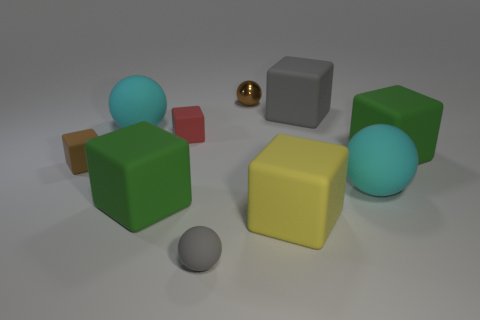Is the number of small brown rubber blocks less than the number of purple shiny cylinders?
Your answer should be compact. No. Are there more small cubes that are behind the small brown metallic ball than metal things to the right of the tiny brown block?
Make the answer very short. No. Is the material of the red block the same as the big yellow cube?
Offer a very short reply. Yes. What number of yellow rubber objects are behind the cyan matte ball left of the tiny gray object?
Make the answer very short. 0. There is a big matte sphere that is behind the tiny brown rubber thing; does it have the same color as the small rubber ball?
Your response must be concise. No. How many things are brown rubber cubes or rubber spheres that are in front of the brown rubber object?
Keep it short and to the point. 3. Does the gray rubber thing in front of the small red matte cube have the same shape as the small red matte object in front of the small brown ball?
Your response must be concise. No. Are there any other things that have the same color as the metallic ball?
Offer a very short reply. Yes. There is a brown object that is the same material as the red object; what shape is it?
Your answer should be very brief. Cube. What material is the tiny thing that is both in front of the tiny red rubber cube and on the right side of the tiny brown matte thing?
Offer a very short reply. Rubber. 